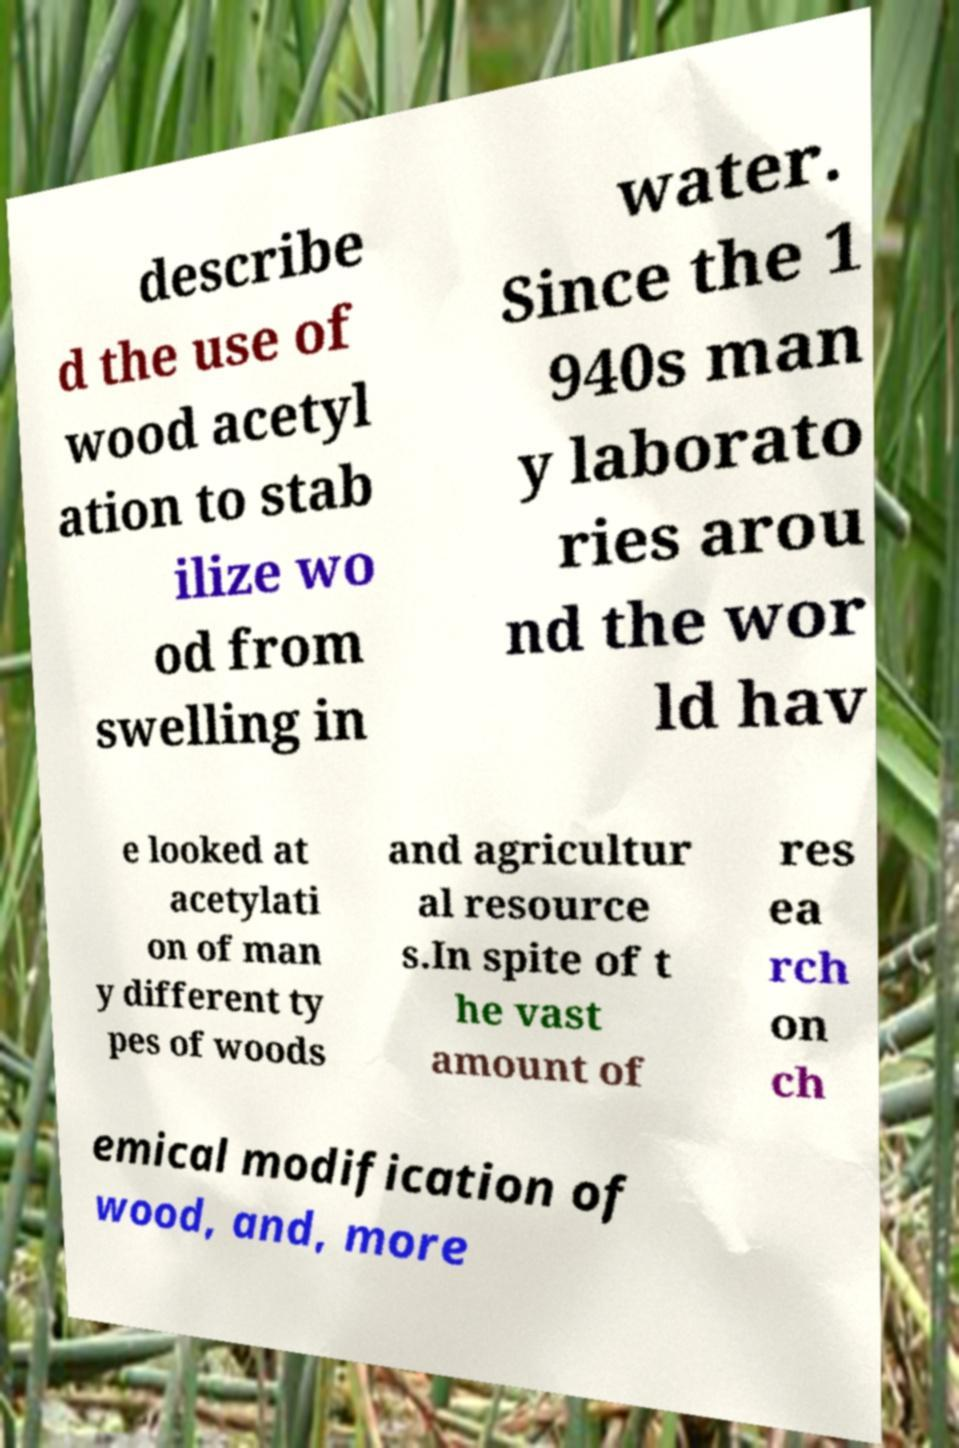For documentation purposes, I need the text within this image transcribed. Could you provide that? describe d the use of wood acetyl ation to stab ilize wo od from swelling in water. Since the 1 940s man y laborato ries arou nd the wor ld hav e looked at acetylati on of man y different ty pes of woods and agricultur al resource s.In spite of t he vast amount of res ea rch on ch emical modification of wood, and, more 